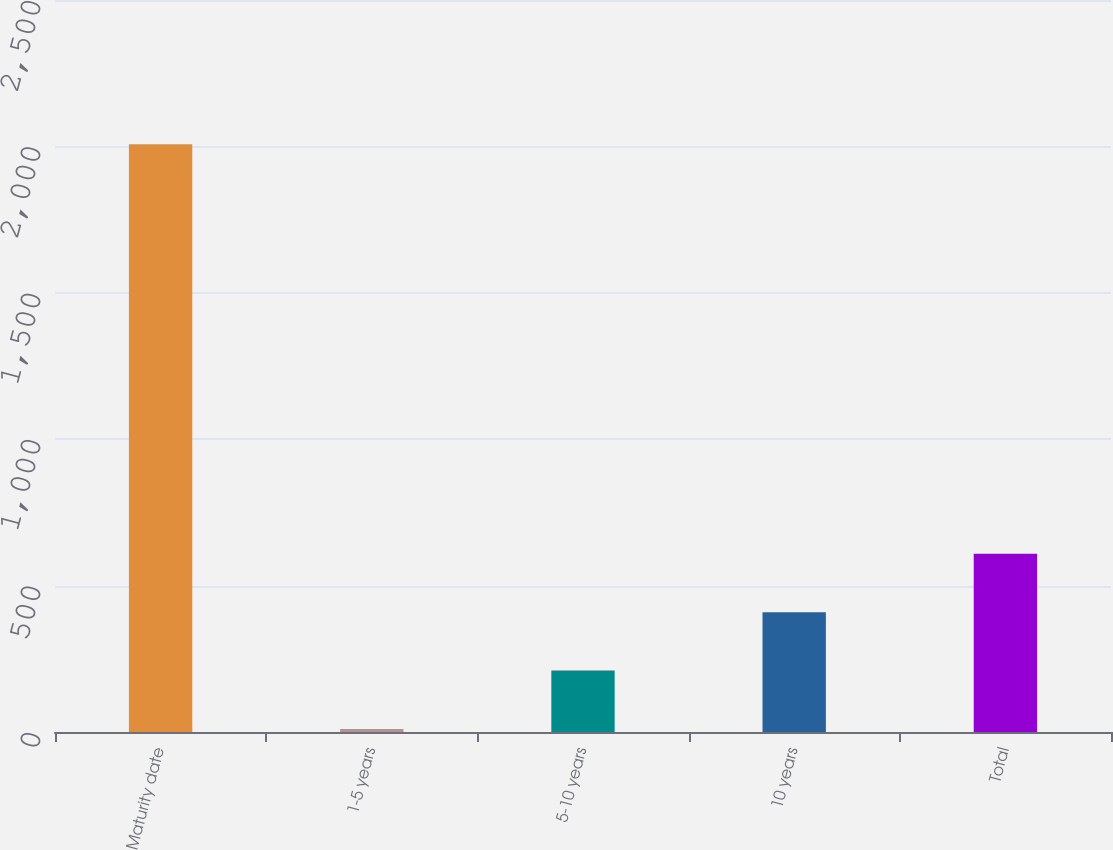Convert chart. <chart><loc_0><loc_0><loc_500><loc_500><bar_chart><fcel>Maturity date<fcel>1-5 years<fcel>5-10 years<fcel>10 years<fcel>Total<nl><fcel>2007<fcel>10<fcel>209.7<fcel>409.4<fcel>609.1<nl></chart> 